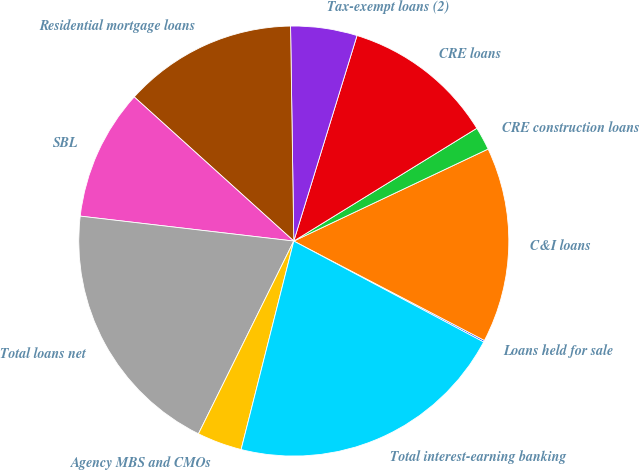<chart> <loc_0><loc_0><loc_500><loc_500><pie_chart><fcel>Loans held for sale<fcel>C&I loans<fcel>CRE construction loans<fcel>CRE loans<fcel>Tax-exempt loans (2)<fcel>Residential mortgage loans<fcel>SBL<fcel>Total loans net<fcel>Agency MBS and CMOs<fcel>Total interest-earning banking<nl><fcel>0.13%<fcel>14.69%<fcel>1.75%<fcel>11.46%<fcel>4.99%<fcel>13.07%<fcel>9.84%<fcel>19.54%<fcel>3.37%<fcel>21.16%<nl></chart> 